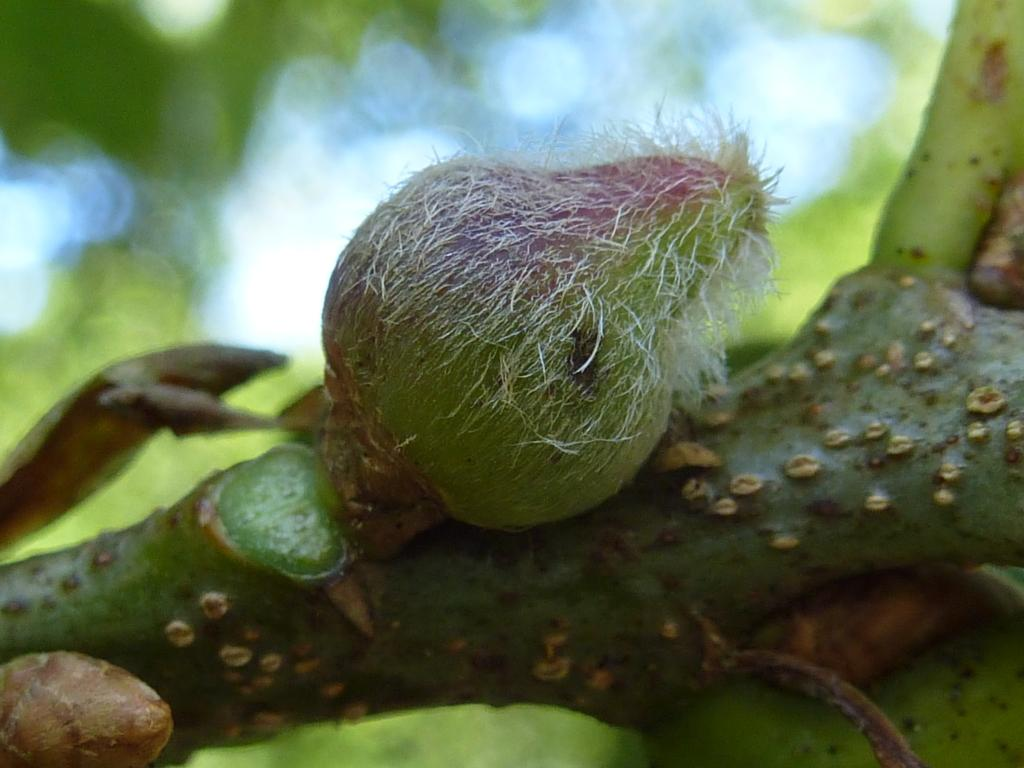What is the color of the stem in the image? The stem in the image is green. What is on the stem, and what are its colors? There is an item on the stem that is green with white pieces. What color is the background of the image? The background of the image is green. Can you hear the horn in the image? There is no horn present in the image, so it cannot be heard. 